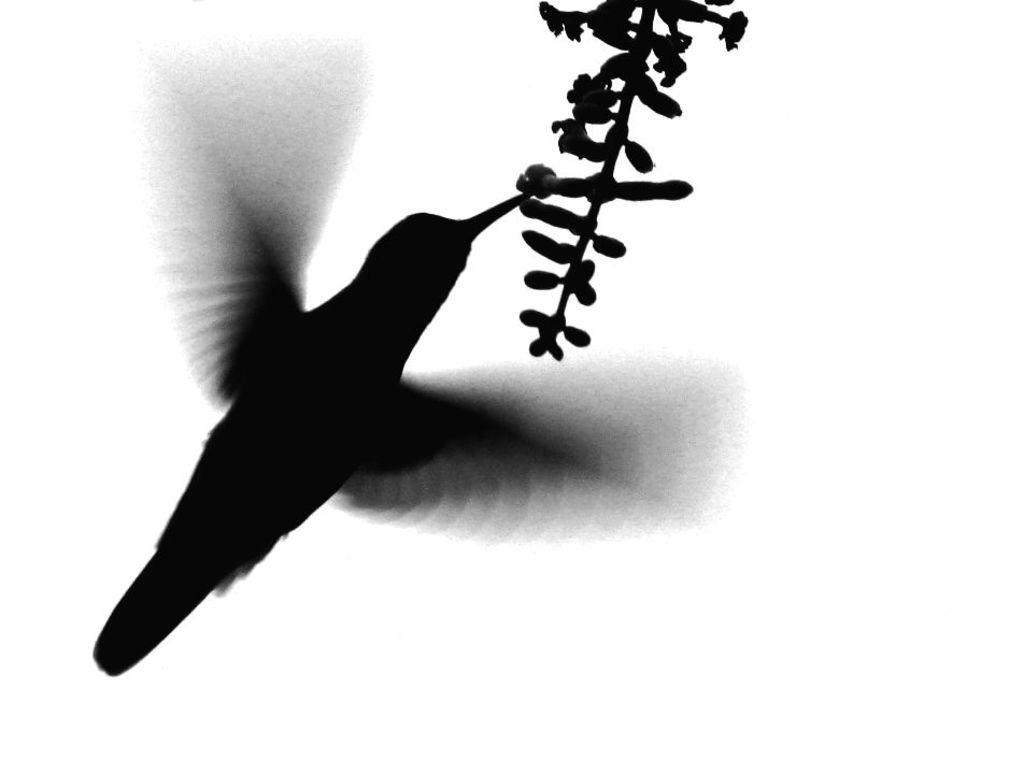What is depicted in the image? The image contains an art of a bird. What features does the bird in the art have? The bird in the art has feathers and wings. What other element is present in the image? There is a plant in the image. How does the bird in the art generate heat for its nest? The bird in the art does not generate heat for its nest, as it is a two-dimensional representation and not a living creature. What type of nose does the bird in the art have? The bird in the art does not have a nose, as it is a bird and not a mammal. 